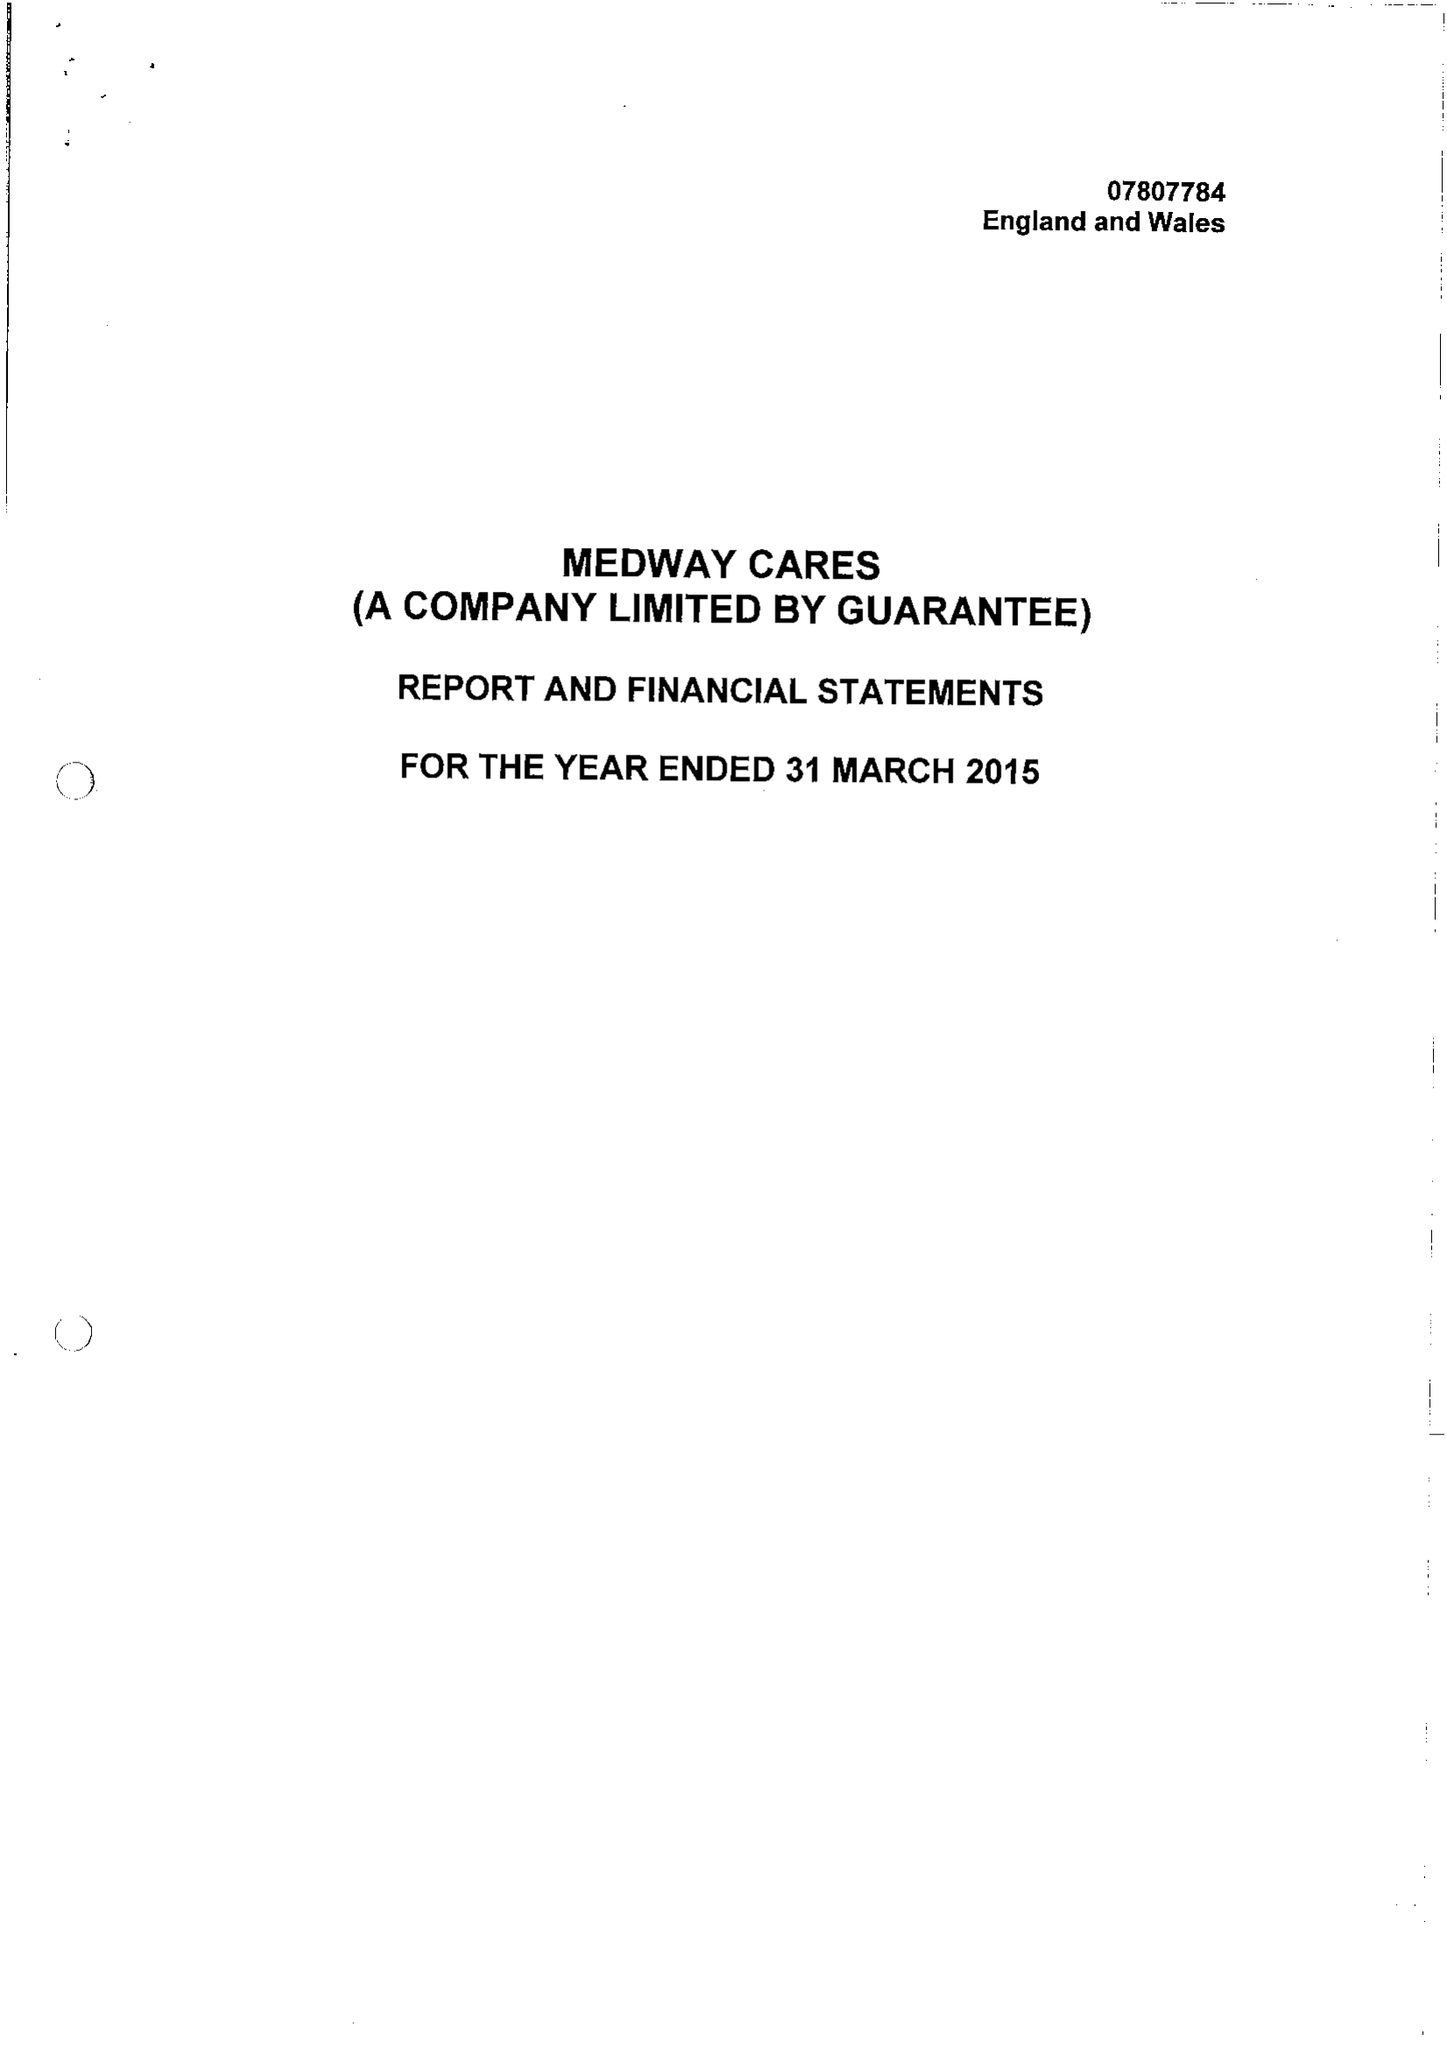What is the value for the address__post_town?
Answer the question using a single word or phrase. GILLINGHAM 